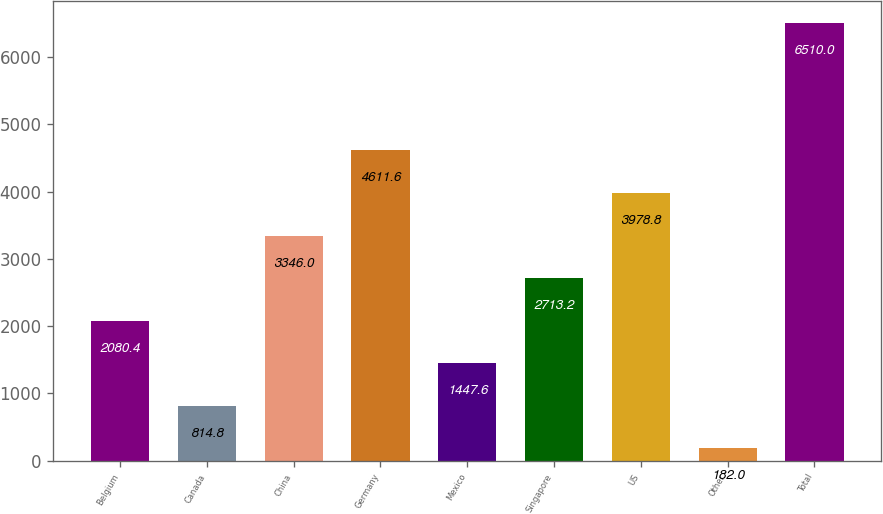Convert chart. <chart><loc_0><loc_0><loc_500><loc_500><bar_chart><fcel>Belgium<fcel>Canada<fcel>China<fcel>Germany<fcel>Mexico<fcel>Singapore<fcel>US<fcel>Other<fcel>Total<nl><fcel>2080.4<fcel>814.8<fcel>3346<fcel>4611.6<fcel>1447.6<fcel>2713.2<fcel>3978.8<fcel>182<fcel>6510<nl></chart> 